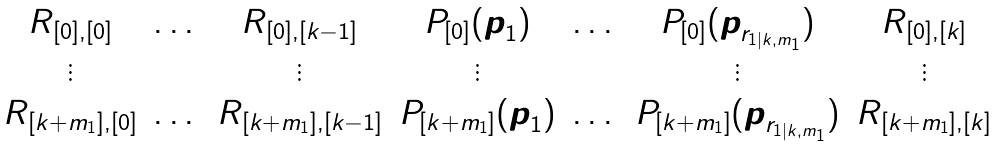Convert formula to latex. <formula><loc_0><loc_0><loc_500><loc_500>\begin{matrix} R _ { [ 0 ] , [ 0 ] } & \dots & R _ { [ 0 ] , [ k - 1 ] } & P _ { [ 0 ] } ( \boldsymbol p _ { 1 } ) & \dots & P _ { [ 0 ] } ( \boldsymbol p _ { r _ { 1 | k , m _ { 1 } } } ) & R _ { [ 0 ] , [ k ] } \\ \vdots & & \vdots & \vdots & & \vdots & \vdots \\ R _ { [ k + m _ { 1 } ] , [ 0 ] } & \dots & R _ { [ k + m _ { 1 } ] , [ k - 1 ] } & P _ { [ k + m _ { 1 } ] } ( \boldsymbol p _ { 1 } ) & \dots & P _ { [ k + m _ { 1 } ] } ( \boldsymbol p _ { r _ { 1 | k , m _ { 1 } } } ) & R _ { [ k + m _ { 1 } ] , [ k ] } \end{matrix}</formula> 